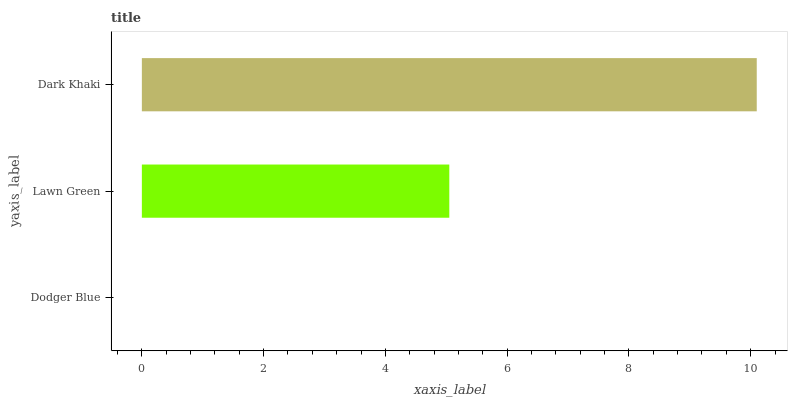Is Dodger Blue the minimum?
Answer yes or no. Yes. Is Dark Khaki the maximum?
Answer yes or no. Yes. Is Lawn Green the minimum?
Answer yes or no. No. Is Lawn Green the maximum?
Answer yes or no. No. Is Lawn Green greater than Dodger Blue?
Answer yes or no. Yes. Is Dodger Blue less than Lawn Green?
Answer yes or no. Yes. Is Dodger Blue greater than Lawn Green?
Answer yes or no. No. Is Lawn Green less than Dodger Blue?
Answer yes or no. No. Is Lawn Green the high median?
Answer yes or no. Yes. Is Lawn Green the low median?
Answer yes or no. Yes. Is Dodger Blue the high median?
Answer yes or no. No. Is Dark Khaki the low median?
Answer yes or no. No. 